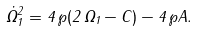<formula> <loc_0><loc_0><loc_500><loc_500>\dot { \Omega } _ { 1 } ^ { 2 } = 4 \, \wp ( 2 \, \Omega _ { 1 } - C ) - 4 \, \wp A .</formula> 